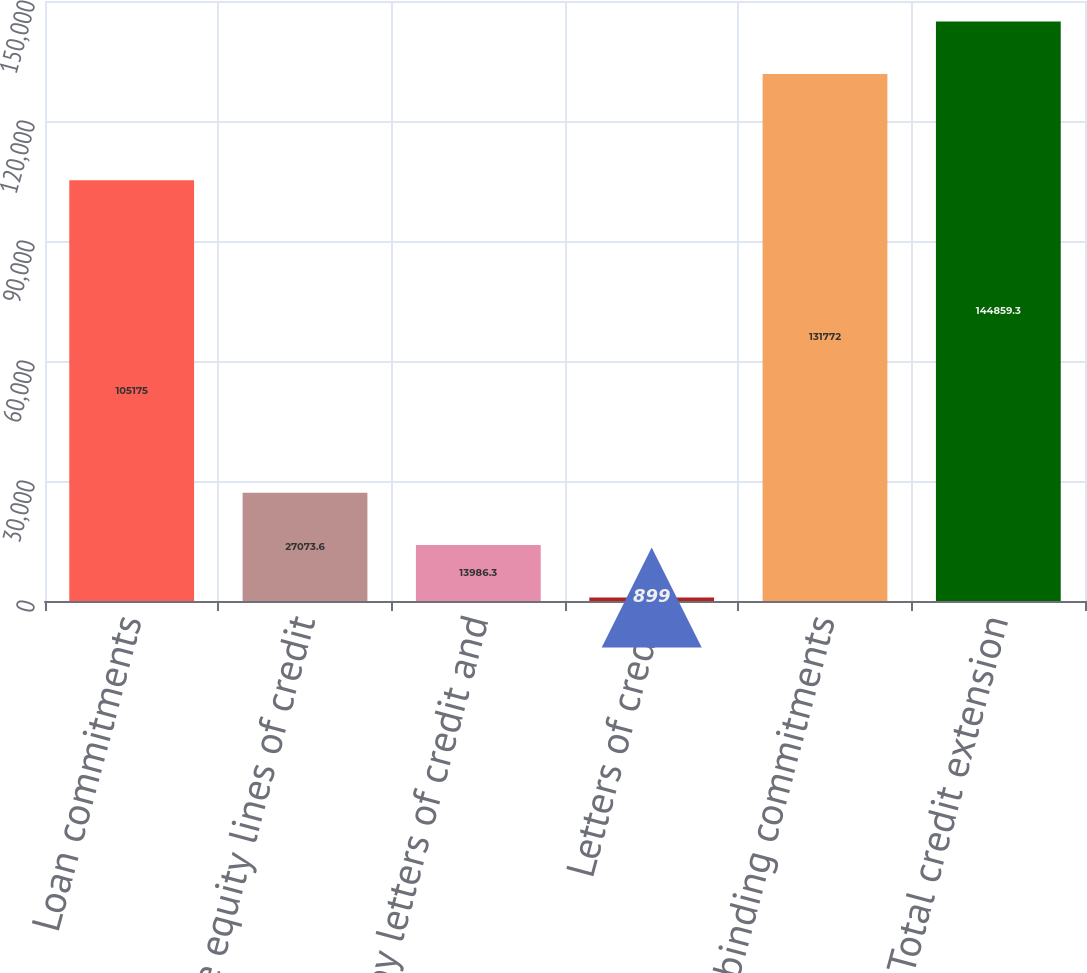Convert chart. <chart><loc_0><loc_0><loc_500><loc_500><bar_chart><fcel>Loan commitments<fcel>Home equity lines of credit<fcel>Standby letters of credit and<fcel>Letters of credit<fcel>Legally binding commitments<fcel>Total credit extension<nl><fcel>105175<fcel>27073.6<fcel>13986.3<fcel>899<fcel>131772<fcel>144859<nl></chart> 